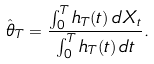<formula> <loc_0><loc_0><loc_500><loc_500>\hat { \theta } _ { T } = \frac { \int _ { 0 } ^ { T } h _ { T } ( t ) \, d X _ { t } } { \int _ { 0 } ^ { T } h _ { T } ( t ) \, d t } .</formula> 